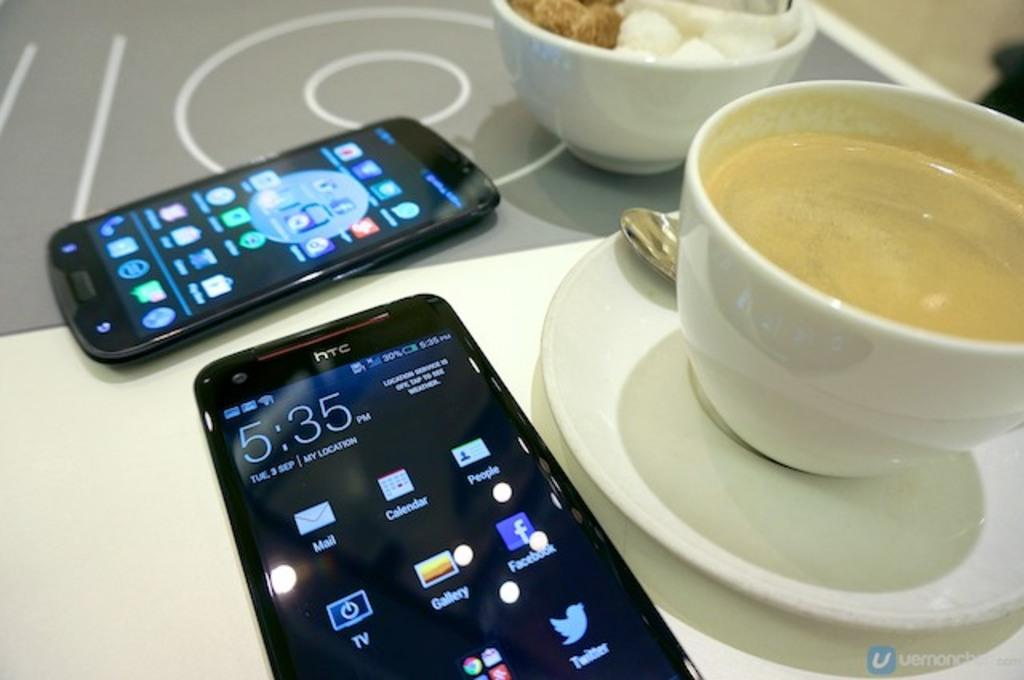<image>
Describe the image concisely. Two phones, one branded HTC, sit on a table with cups of coffee. 